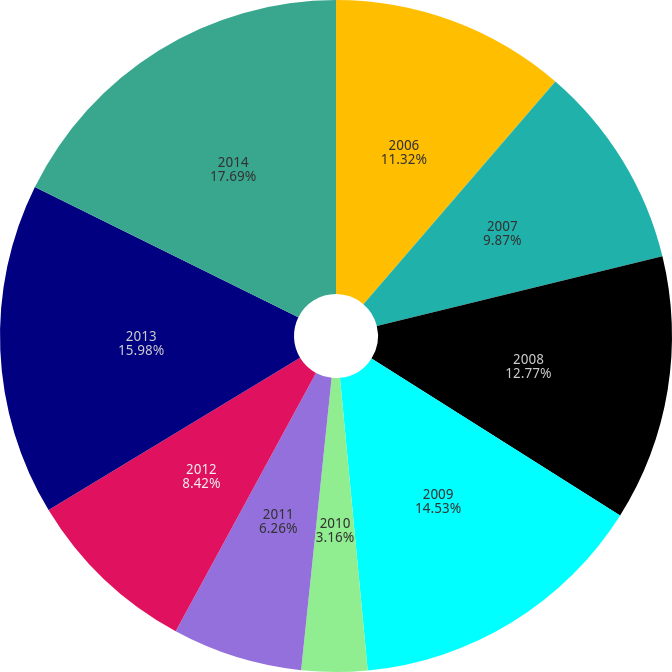Convert chart. <chart><loc_0><loc_0><loc_500><loc_500><pie_chart><fcel>2006<fcel>2007<fcel>2008<fcel>2009<fcel>2010<fcel>2011<fcel>2012<fcel>2013<fcel>2014<nl><fcel>11.32%<fcel>9.87%<fcel>12.77%<fcel>14.53%<fcel>3.16%<fcel>6.26%<fcel>8.42%<fcel>15.98%<fcel>17.68%<nl></chart> 